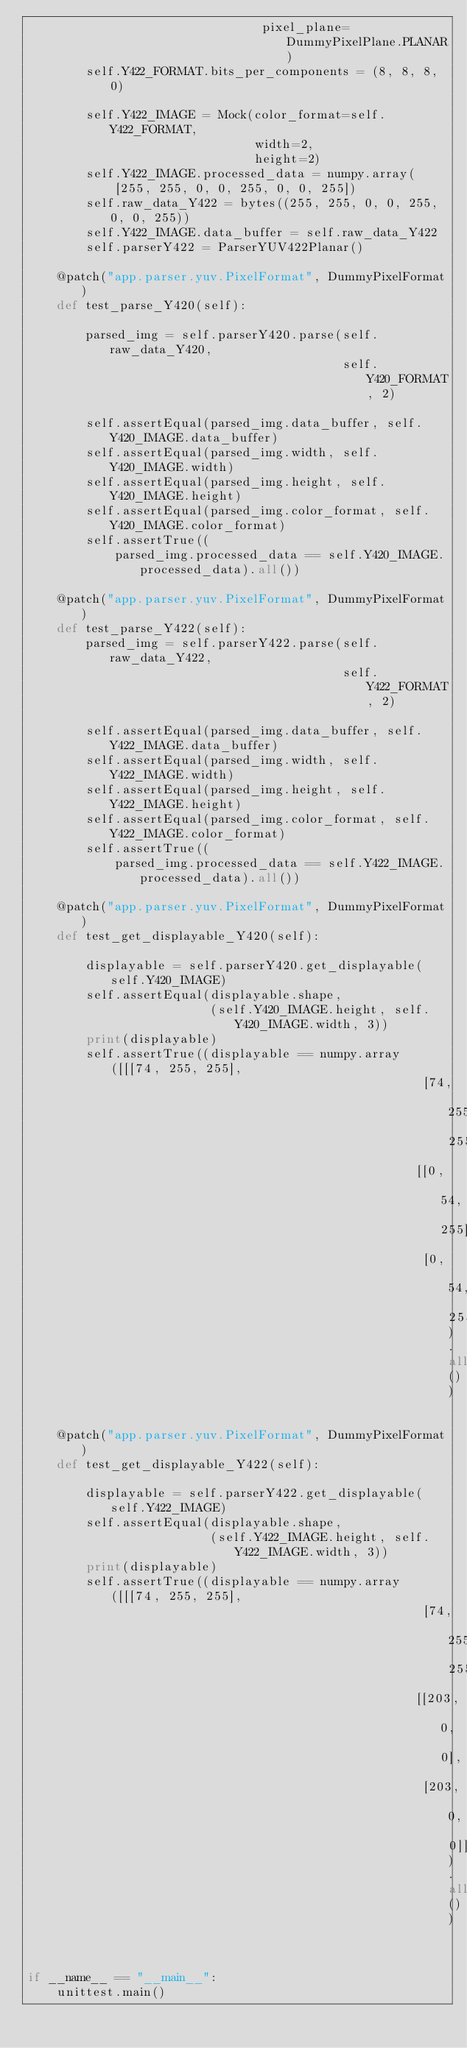Convert code to text. <code><loc_0><loc_0><loc_500><loc_500><_Python_>                                pixel_plane=DummyPixelPlane.PLANAR)
        self.Y422_FORMAT.bits_per_components = (8, 8, 8, 0)

        self.Y422_IMAGE = Mock(color_format=self.Y422_FORMAT,
                               width=2,
                               height=2)
        self.Y422_IMAGE.processed_data = numpy.array(
            [255, 255, 0, 0, 255, 0, 0, 255])
        self.raw_data_Y422 = bytes((255, 255, 0, 0, 255, 0, 0, 255))
        self.Y422_IMAGE.data_buffer = self.raw_data_Y422
        self.parserY422 = ParserYUV422Planar()

    @patch("app.parser.yuv.PixelFormat", DummyPixelFormat)
    def test_parse_Y420(self):

        parsed_img = self.parserY420.parse(self.raw_data_Y420,
                                           self.Y420_FORMAT, 2)

        self.assertEqual(parsed_img.data_buffer, self.Y420_IMAGE.data_buffer)
        self.assertEqual(parsed_img.width, self.Y420_IMAGE.width)
        self.assertEqual(parsed_img.height, self.Y420_IMAGE.height)
        self.assertEqual(parsed_img.color_format, self.Y420_IMAGE.color_format)
        self.assertTrue((
            parsed_img.processed_data == self.Y420_IMAGE.processed_data).all())

    @patch("app.parser.yuv.PixelFormat", DummyPixelFormat)
    def test_parse_Y422(self):
        parsed_img = self.parserY422.parse(self.raw_data_Y422,
                                           self.Y422_FORMAT, 2)

        self.assertEqual(parsed_img.data_buffer, self.Y422_IMAGE.data_buffer)
        self.assertEqual(parsed_img.width, self.Y422_IMAGE.width)
        self.assertEqual(parsed_img.height, self.Y422_IMAGE.height)
        self.assertEqual(parsed_img.color_format, self.Y422_IMAGE.color_format)
        self.assertTrue((
            parsed_img.processed_data == self.Y422_IMAGE.processed_data).all())

    @patch("app.parser.yuv.PixelFormat", DummyPixelFormat)
    def test_get_displayable_Y420(self):

        displayable = self.parserY420.get_displayable(self.Y420_IMAGE)
        self.assertEqual(displayable.shape,
                         (self.Y420_IMAGE.height, self.Y420_IMAGE.width, 3))
        print(displayable)
        self.assertTrue((displayable == numpy.array([[[74, 255, 255],
                                                      [74, 255, 255]],
                                                     [[0, 54, 255],
                                                      [0, 54, 255]]])).all())

    @patch("app.parser.yuv.PixelFormat", DummyPixelFormat)
    def test_get_displayable_Y422(self):

        displayable = self.parserY422.get_displayable(self.Y422_IMAGE)
        self.assertEqual(displayable.shape,
                         (self.Y422_IMAGE.height, self.Y422_IMAGE.width, 3))
        print(displayable)
        self.assertTrue((displayable == numpy.array([[[74, 255, 255],
                                                      [74, 255, 255]],
                                                     [[203, 0, 0],
                                                      [203, 0, 0]]])).all())


if __name__ == "__main__":
    unittest.main()</code> 